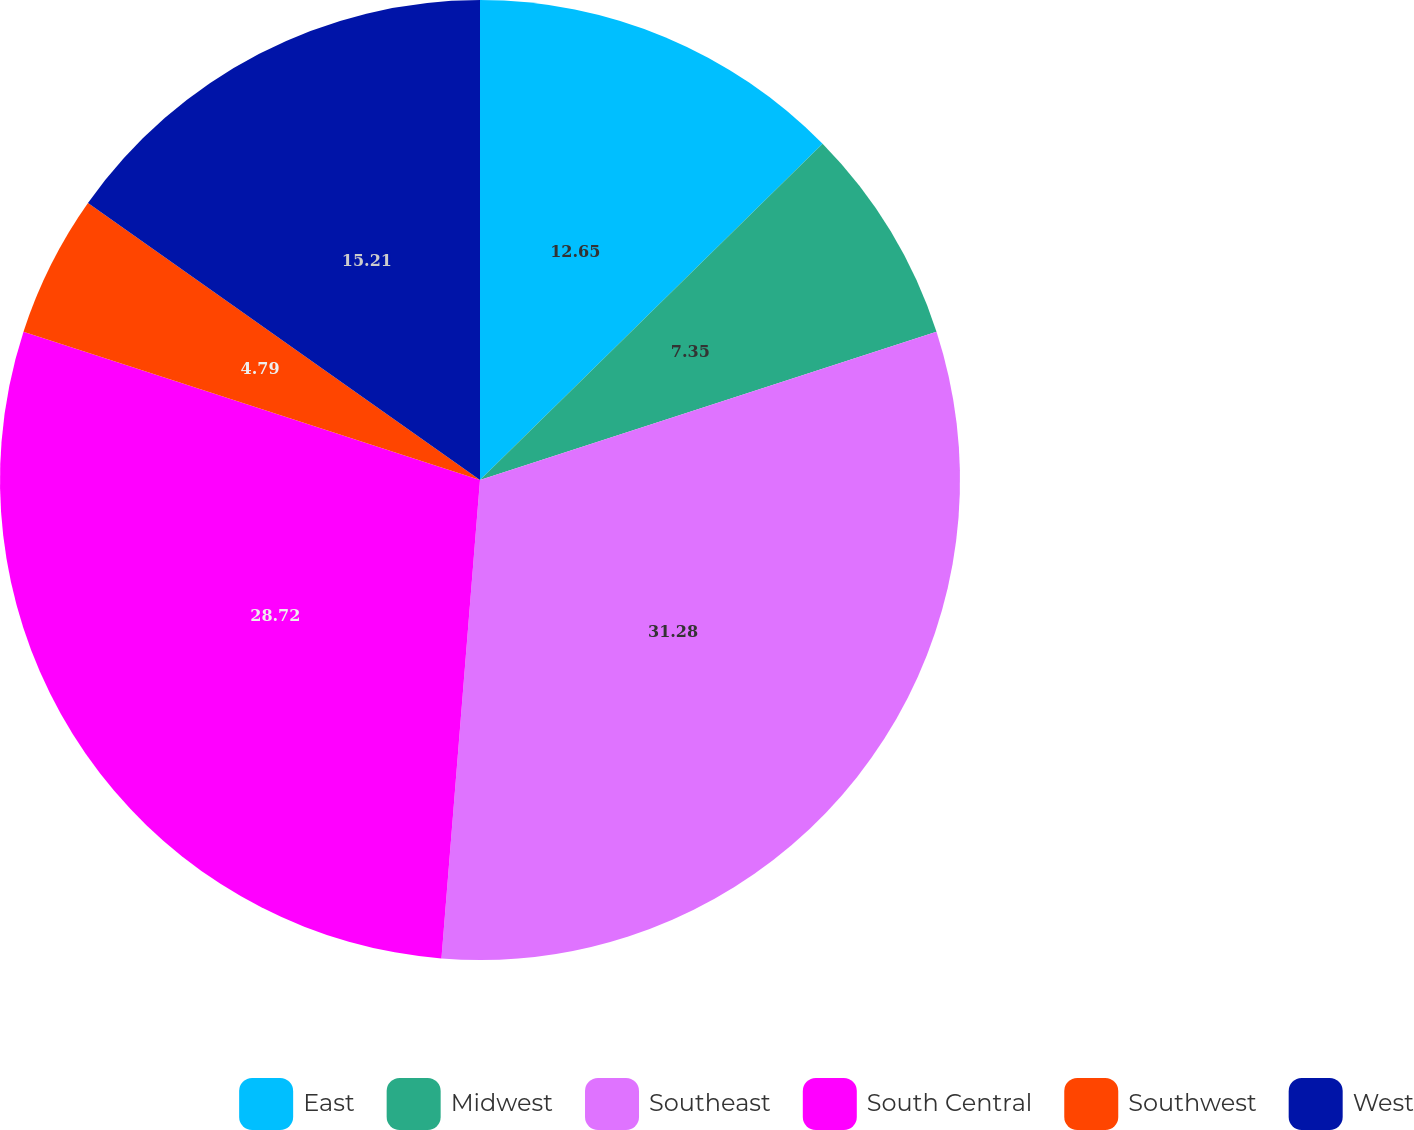<chart> <loc_0><loc_0><loc_500><loc_500><pie_chart><fcel>East<fcel>Midwest<fcel>Southeast<fcel>South Central<fcel>Southwest<fcel>West<nl><fcel>12.65%<fcel>7.35%<fcel>31.28%<fcel>28.72%<fcel>4.79%<fcel>15.21%<nl></chart> 